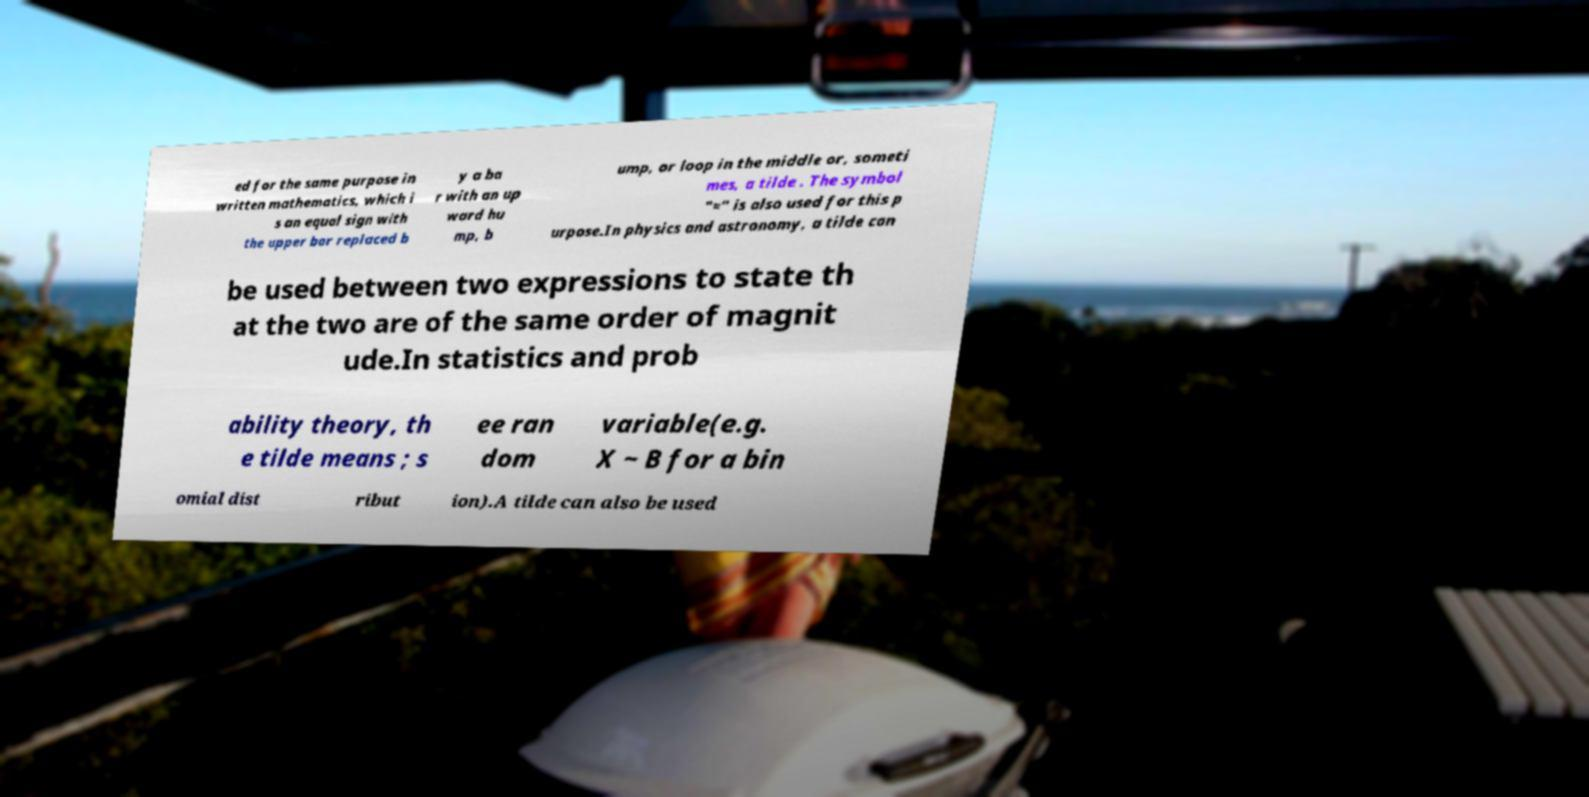For documentation purposes, I need the text within this image transcribed. Could you provide that? ed for the same purpose in written mathematics, which i s an equal sign with the upper bar replaced b y a ba r with an up ward hu mp, b ump, or loop in the middle or, someti mes, a tilde . The symbol "≈" is also used for this p urpose.In physics and astronomy, a tilde can be used between two expressions to state th at the two are of the same order of magnit ude.In statistics and prob ability theory, th e tilde means ; s ee ran dom variable(e.g. X ~ B for a bin omial dist ribut ion).A tilde can also be used 